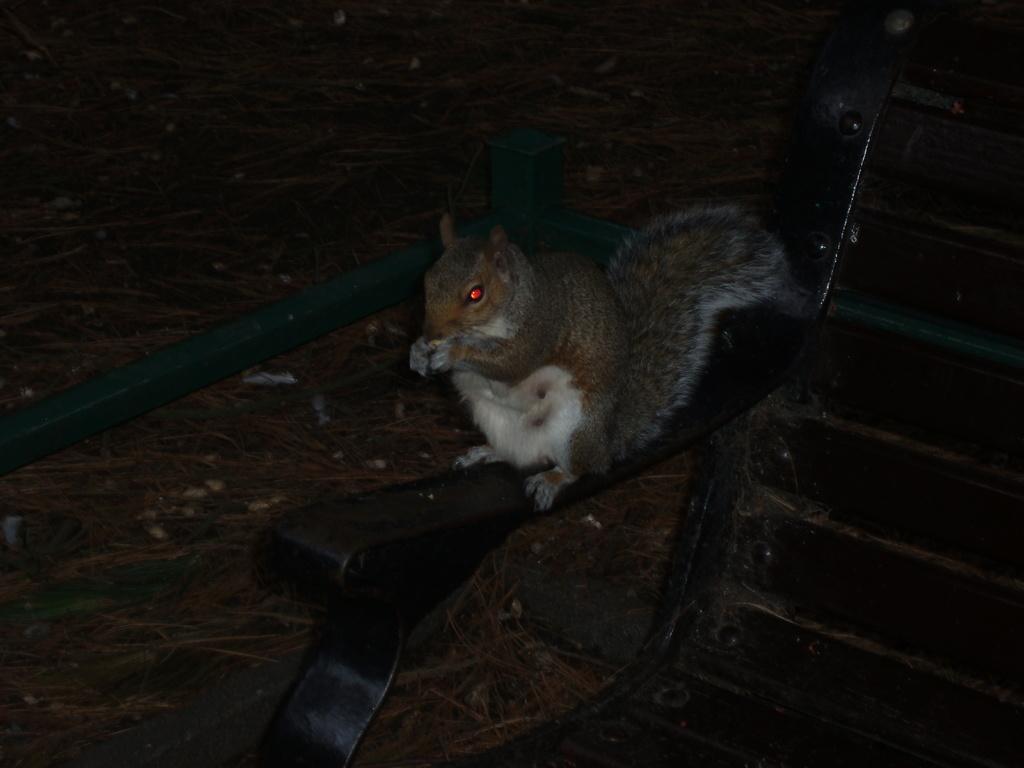Can you describe this image briefly? In this image we can see a squirrel on the chair. In the background we can see the dried grass. 